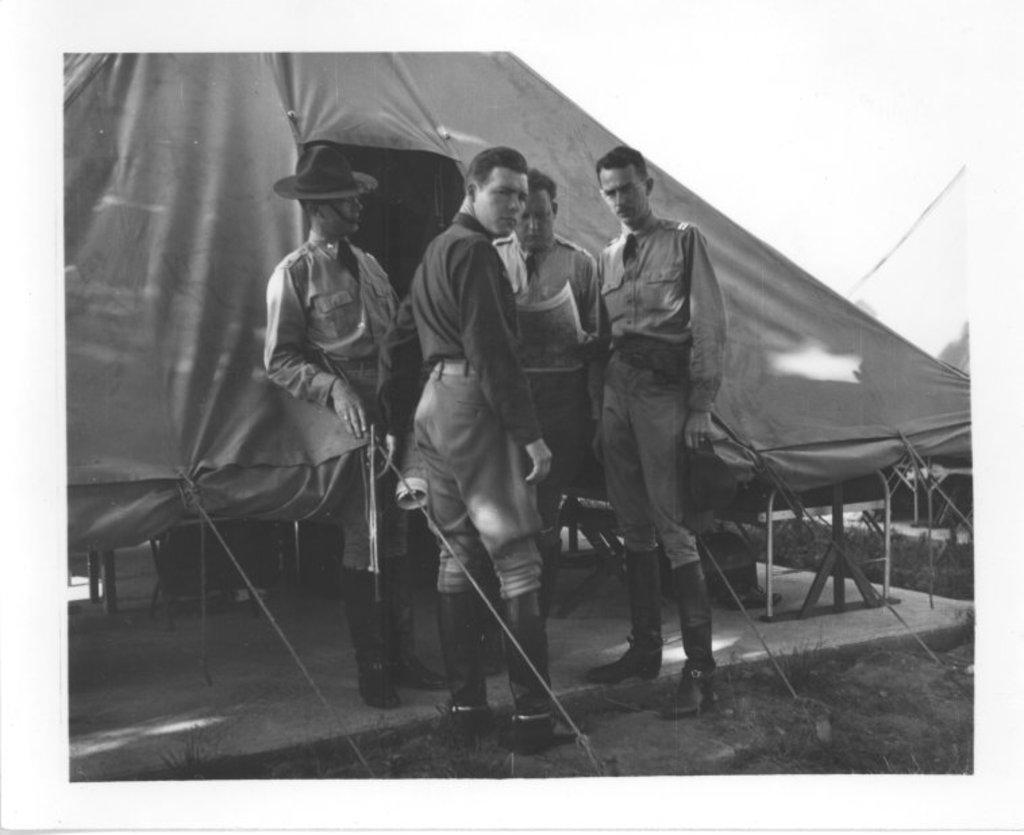Can you describe this image briefly? As we can see in the image there are few people here and there, grass and tent. On the top there is a sky. 